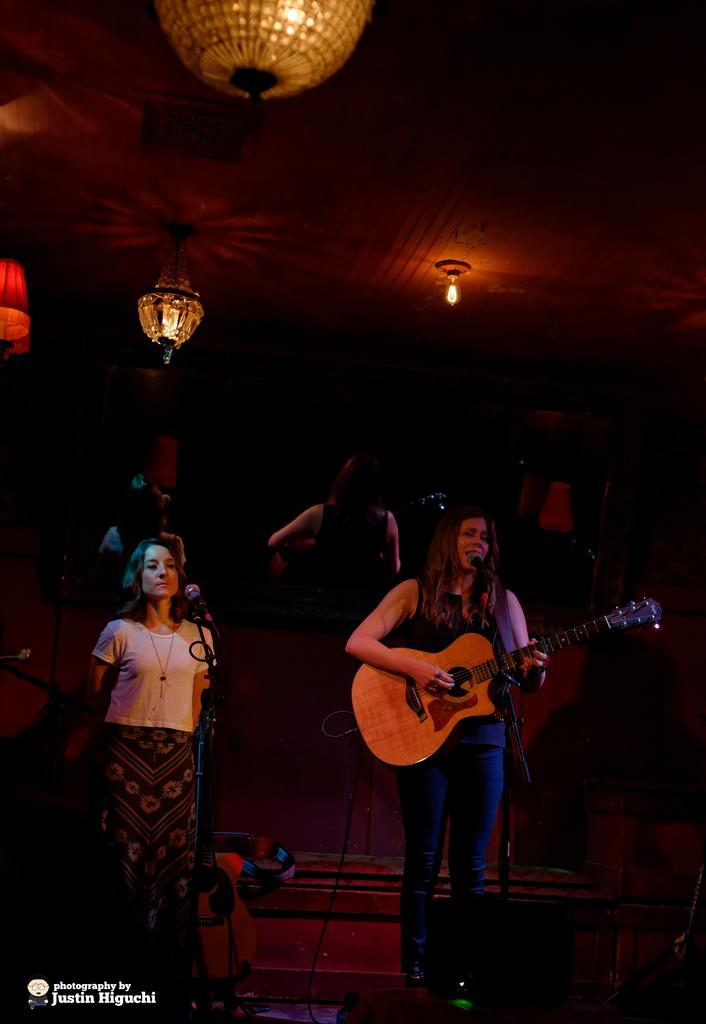How many people are in the image? There are two women in the image. What are the women doing in the image? The women are standing in front of microphones. What instrument is one of the women holding? One of the women is holding a guitar. What can be seen in the background of the image? There are lights visible in the background of the image. What type of mint is growing near the microphones in the image? There is no mint present in the image; it features two women standing in front of microphones, one of whom is holding a guitar. 